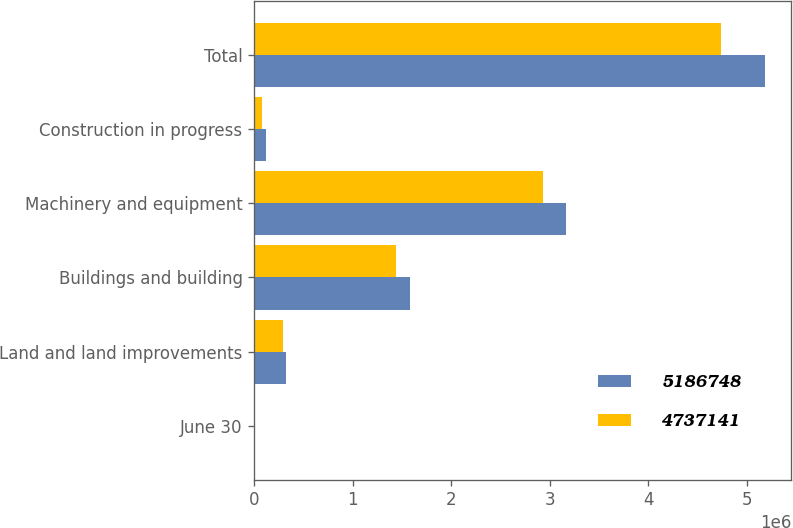<chart> <loc_0><loc_0><loc_500><loc_500><stacked_bar_chart><ecel><fcel>June 30<fcel>Land and land improvements<fcel>Buildings and building<fcel>Machinery and equipment<fcel>Construction in progress<fcel>Total<nl><fcel>5.18675e+06<fcel>2017<fcel>321331<fcel>1.57546e+06<fcel>3.16788e+06<fcel>122068<fcel>5.18675e+06<nl><fcel>4.73714e+06<fcel>2016<fcel>291122<fcel>1.4376e+06<fcel>2.93382e+06<fcel>74600<fcel>4.73714e+06<nl></chart> 